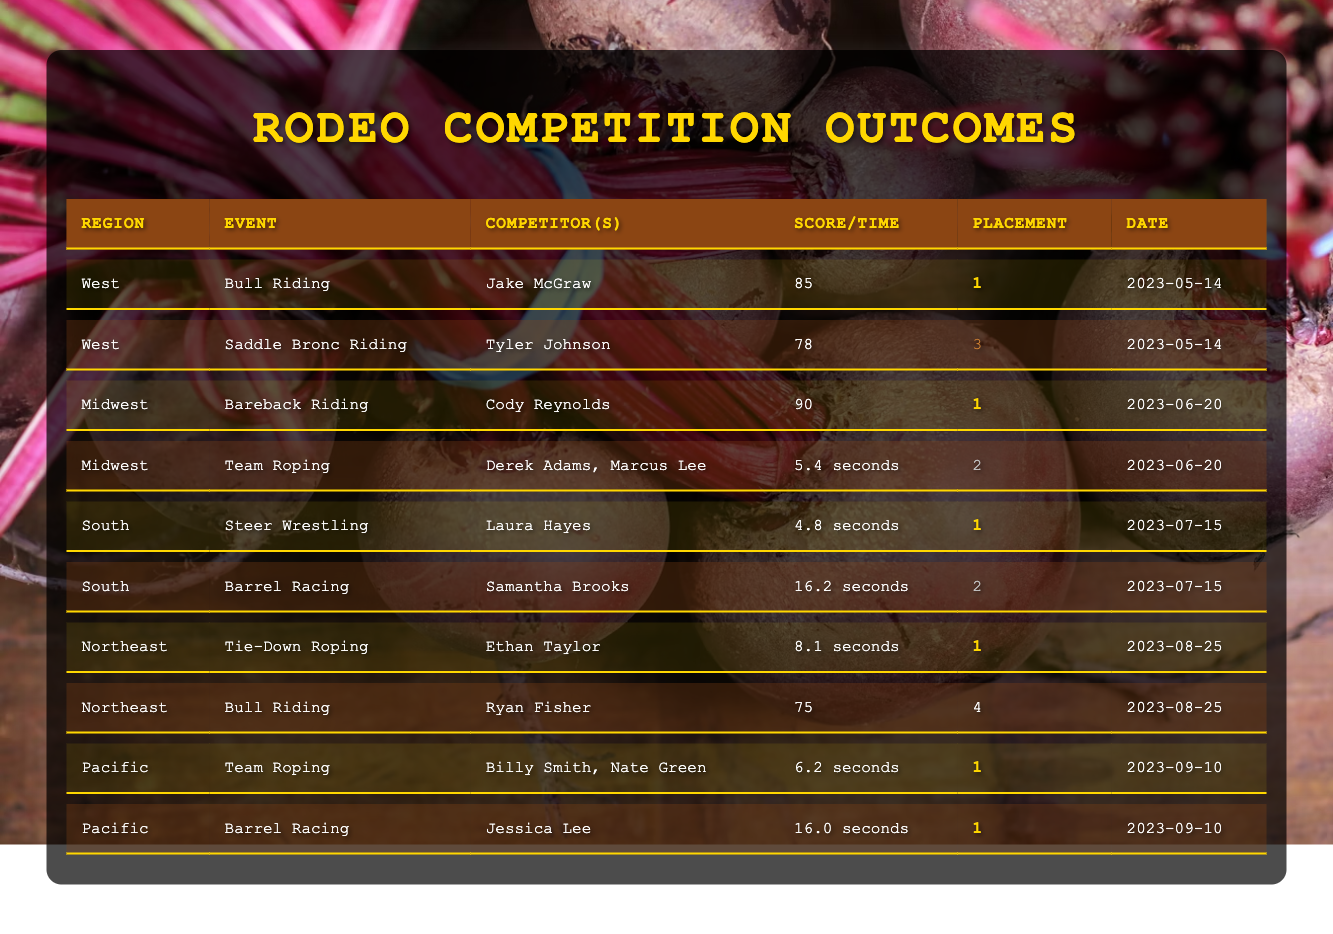What region had the highest score in Bull Riding? By looking at the Bull Riding event, Jake McGraw scored 85 in the West and Ryan Fisher scored 75 in the Northeast. Since 85 is greater than 75, the West had the highest score.
Answer: West Who placed second in Team Roping? In the Midwest, Derek Adams and Marcus Lee placed second with a time of 5.4 seconds. Additionally, Billy Smith and Nate Green also placed first with a time of 6.2 seconds in the Pacific region, but we only need the second placement.
Answer: Derek Adams, Marcus Lee How many events did Laura Hayes compete in? The table shows only one entry for Laura Hayes, who competed in Steer Wrestling. Hence, she participated in one event.
Answer: 1 Which competitor had the highest score across all events? Comparing all individual scores from Bull Riding and Bareback Riding, Cody Reynolds with a score of 90 stands out as the highest. The other scores are 85, 78, and 75 which are all lower than 90.
Answer: Cody Reynolds Did any competitor place first in multiple events? By examining the table, we can see Jake McGraw, Cody Reynolds, Ethan Taylor, Billy Smith, Nate Green, and Jessica Lee each have one first-place finish. There are no instances of any competitor winning more than one event.
Answer: No What is the average score for Bull Riding competitors? The scores for Bull Riding are 85 (Jake McGraw) and 75 (Ryan Fisher). To find the average, sum the scores (85 + 75) = 160 and divide by the number of competitors (2), which gives 160 / 2 = 80.
Answer: 80 In which event did Samantha Brooks compete and what was her placement? Samantha Brooks competed in Barrel Racing, where she placed second. This is evident from her row in the table specifying the event, competitor's name, and placement.
Answer: Barrel Racing, 2nd Which region had the most competitors placing in the top three? Reviewing the placements, the West had one first and one third place, the Midwest had one first and one second, the South had one first and one second, the Northeast had one first and one fourth, and the Pacific had three first places. Hence, the Pacific region had more top placements overall.
Answer: Pacific What was the winning time in Team Roping? The table shows Team Roping results for two regional events. In the Midwest, it was 5.4 seconds for second place and in the Pacific it was 6.2 seconds for first place. The winning time was therefore the faster, which is 6.2 seconds.
Answer: 6.2 seconds 